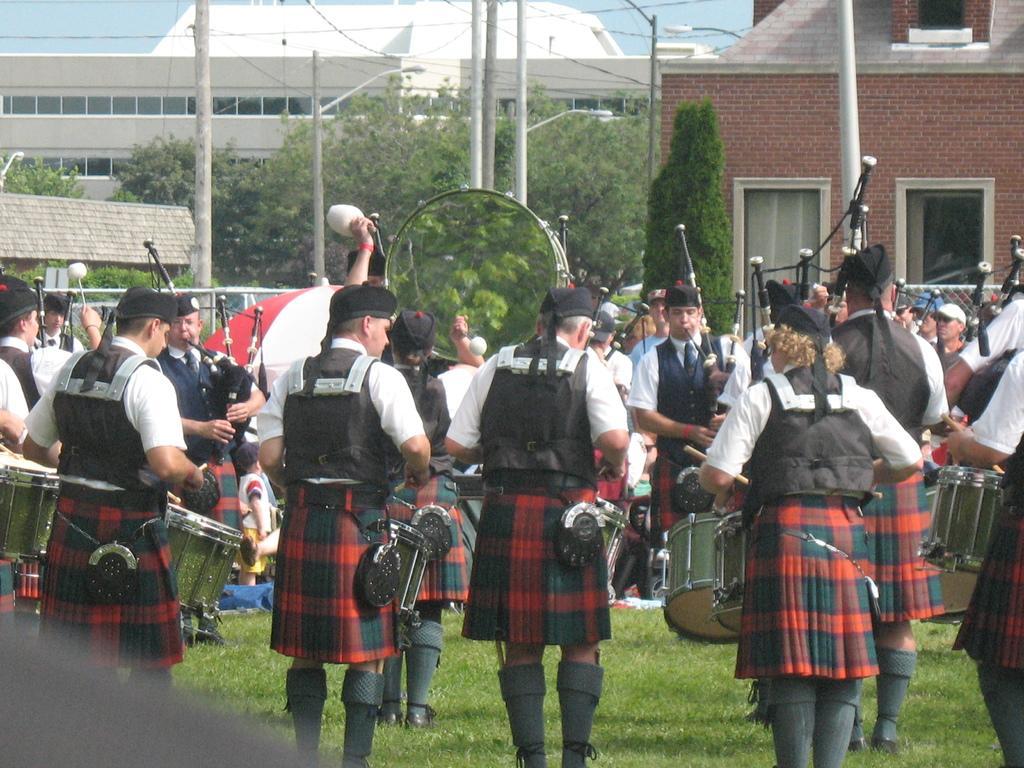Describe this image in one or two sentences. At the bottom of this image, there are persons in the black color jackets, playing musical instruments on the ground, on which there is grass. In the background, there are trees, poles, buildings and there is sky. 